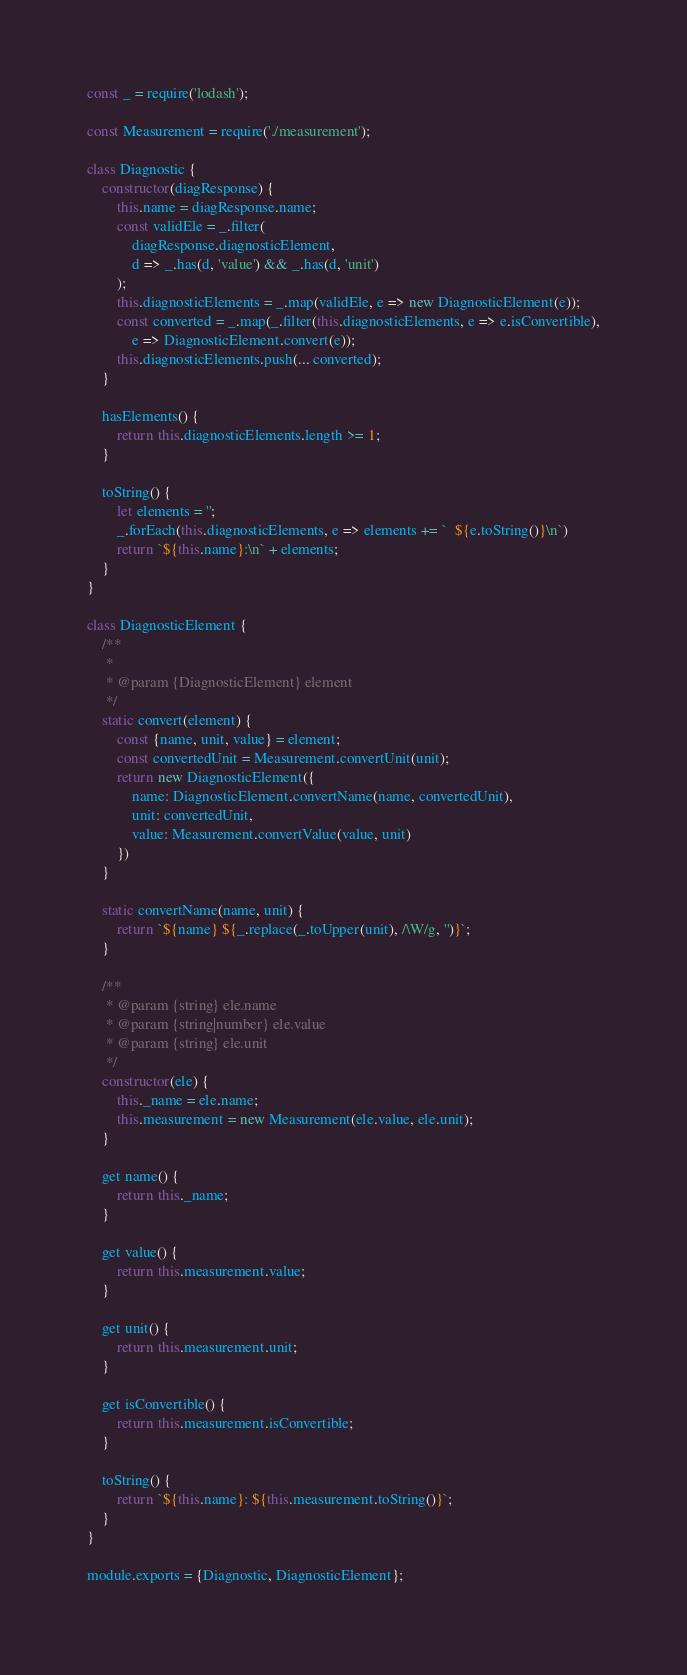<code> <loc_0><loc_0><loc_500><loc_500><_JavaScript_>const _ = require('lodash');

const Measurement = require('./measurement');

class Diagnostic {
    constructor(diagResponse) {
        this.name = diagResponse.name;
        const validEle = _.filter(
            diagResponse.diagnosticElement,
            d => _.has(d, 'value') && _.has(d, 'unit')
        );
        this.diagnosticElements = _.map(validEle, e => new DiagnosticElement(e));
        const converted = _.map(_.filter(this.diagnosticElements, e => e.isConvertible),
            e => DiagnosticElement.convert(e));
        this.diagnosticElements.push(... converted);
    }

    hasElements() {
        return this.diagnosticElements.length >= 1;
    }

    toString() {
        let elements = '';
        _.forEach(this.diagnosticElements, e => elements += `  ${e.toString()}\n`)
        return `${this.name}:\n` + elements;
    }
}

class DiagnosticElement {
    /**
     *
     * @param {DiagnosticElement} element
     */
    static convert(element) {
        const {name, unit, value} = element;
        const convertedUnit = Measurement.convertUnit(unit);
        return new DiagnosticElement({
            name: DiagnosticElement.convertName(name, convertedUnit),
            unit: convertedUnit,
            value: Measurement.convertValue(value, unit)
        })
    }

    static convertName(name, unit) {
        return `${name} ${_.replace(_.toUpper(unit), /\W/g, '')}`;
    }

    /**
     * @param {string} ele.name
     * @param {string|number} ele.value
     * @param {string} ele.unit
     */
    constructor(ele) {
        this._name = ele.name;
        this.measurement = new Measurement(ele.value, ele.unit);
    }

    get name() {
        return this._name;
    }

    get value() {
        return this.measurement.value;
    }

    get unit() {
        return this.measurement.unit;
    }

    get isConvertible() {
        return this.measurement.isConvertible;
    }

    toString() {
        return `${this.name}: ${this.measurement.toString()}`;
    }
}

module.exports = {Diagnostic, DiagnosticElement};</code> 